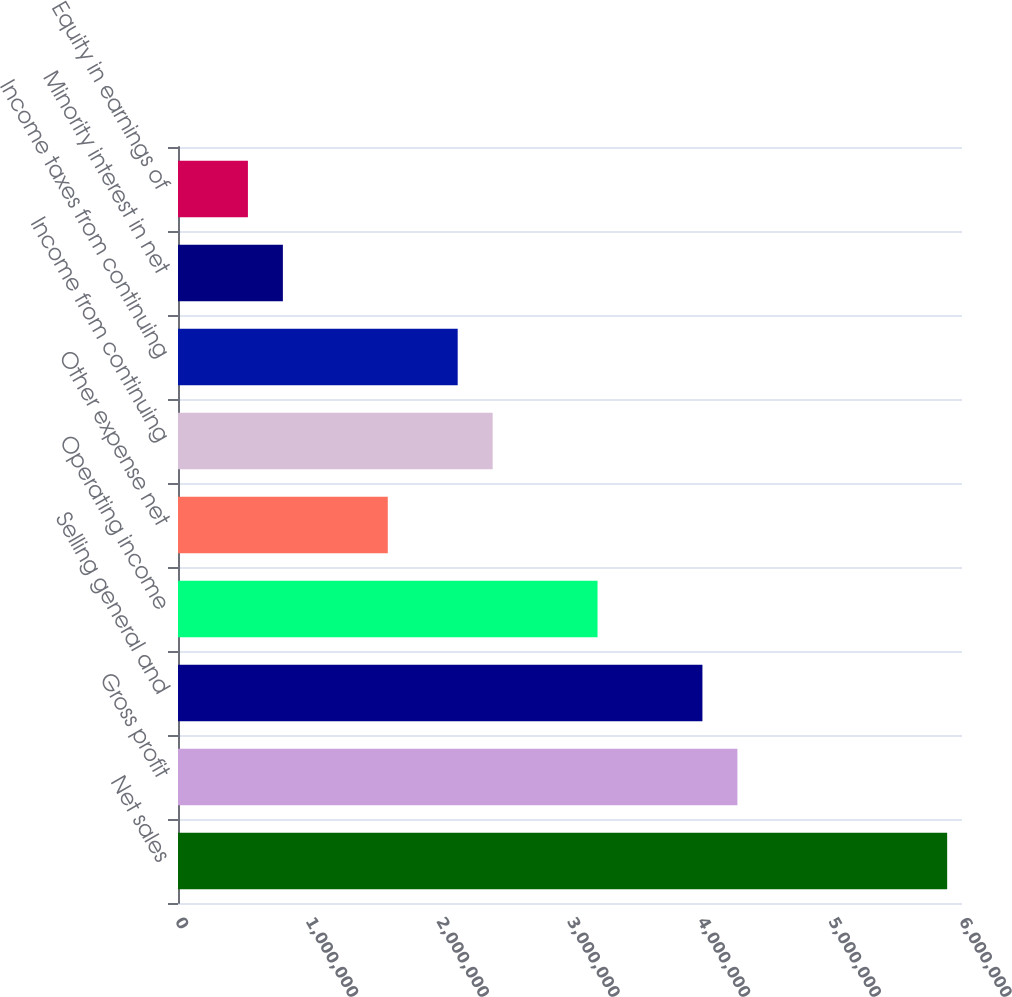Convert chart. <chart><loc_0><loc_0><loc_500><loc_500><bar_chart><fcel>Net sales<fcel>Gross profit<fcel>Selling general and<fcel>Operating income<fcel>Other expense net<fcel>Income from continuing<fcel>Income taxes from continuing<fcel>Minority interest in net<fcel>Equity in earnings of<nl><fcel>5.88642e+06<fcel>4.28103e+06<fcel>4.01347e+06<fcel>3.21077e+06<fcel>1.60539e+06<fcel>2.40808e+06<fcel>2.14052e+06<fcel>802694<fcel>535130<nl></chart> 